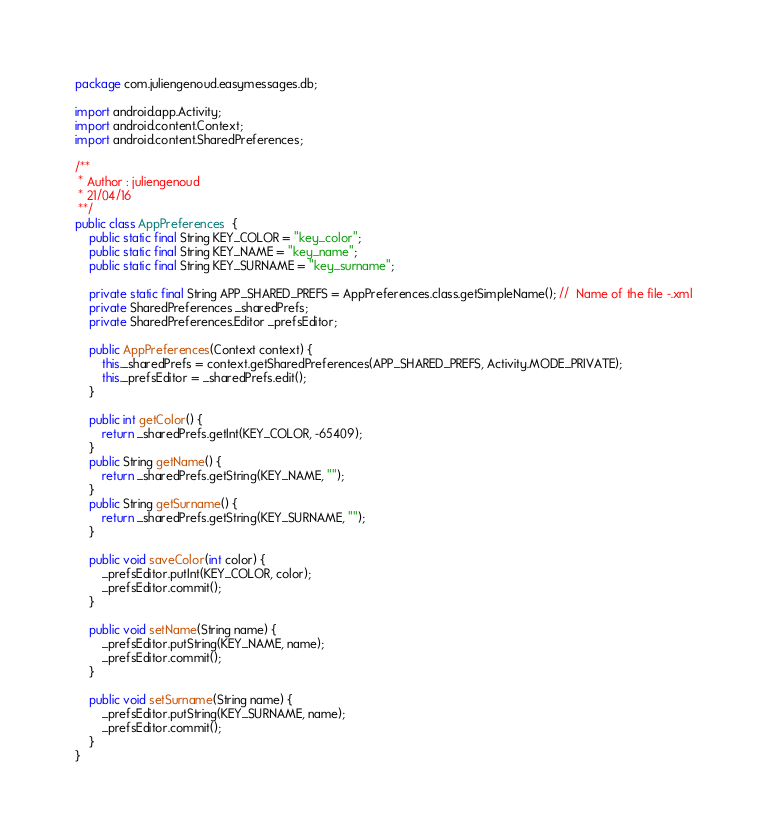<code> <loc_0><loc_0><loc_500><loc_500><_Java_>package com.juliengenoud.easymessages.db;

import android.app.Activity;
import android.content.Context;
import android.content.SharedPreferences;

/**
 * Author : juliengenoud
 * 21/04/16
 **/
public class AppPreferences  {
    public static final String KEY_COLOR = "key_color";
    public static final String KEY_NAME = "key_name";
    public static final String KEY_SURNAME = "key_surname";

    private static final String APP_SHARED_PREFS = AppPreferences.class.getSimpleName(); //  Name of the file -.xml
    private SharedPreferences _sharedPrefs;
    private SharedPreferences.Editor _prefsEditor;

    public AppPreferences(Context context) {
        this._sharedPrefs = context.getSharedPreferences(APP_SHARED_PREFS, Activity.MODE_PRIVATE);
        this._prefsEditor = _sharedPrefs.edit();
    }

    public int getColor() {
        return _sharedPrefs.getInt(KEY_COLOR, -65409);
    }
    public String getName() {
        return _sharedPrefs.getString(KEY_NAME, "");
    }
    public String getSurname() {
        return _sharedPrefs.getString(KEY_SURNAME, "");
    }

    public void saveColor(int color) {
        _prefsEditor.putInt(KEY_COLOR, color);
        _prefsEditor.commit();
    }

    public void setName(String name) {
        _prefsEditor.putString(KEY_NAME, name);
        _prefsEditor.commit();
    }

    public void setSurname(String name) {
        _prefsEditor.putString(KEY_SURNAME, name);
        _prefsEditor.commit();
    }
}</code> 